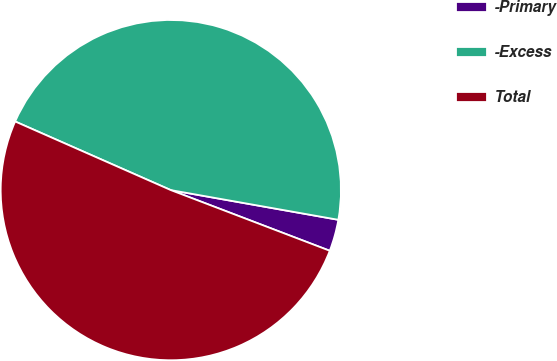Convert chart to OTSL. <chart><loc_0><loc_0><loc_500><loc_500><pie_chart><fcel>-Primary<fcel>-Excess<fcel>Total<nl><fcel>3.01%<fcel>46.19%<fcel>50.81%<nl></chart> 